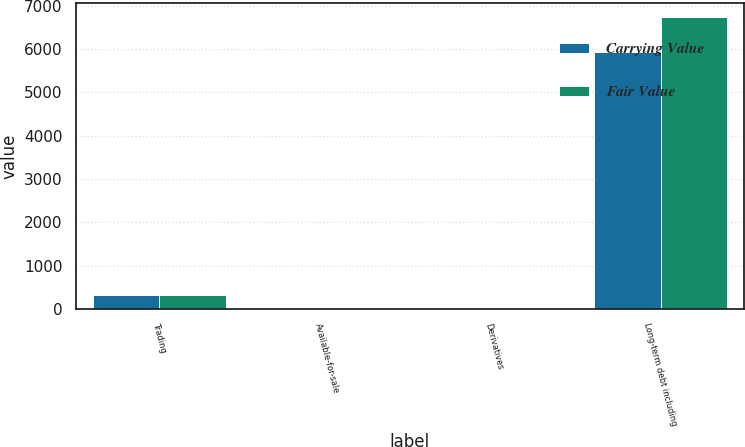Convert chart. <chart><loc_0><loc_0><loc_500><loc_500><stacked_bar_chart><ecel><fcel>Trading<fcel>Available-for-sale<fcel>Derivatives<fcel>Long-term debt including<nl><fcel>Carrying Value<fcel>331<fcel>5<fcel>1<fcel>5928<nl><fcel>Fair Value<fcel>331<fcel>5<fcel>1<fcel>6726<nl></chart> 